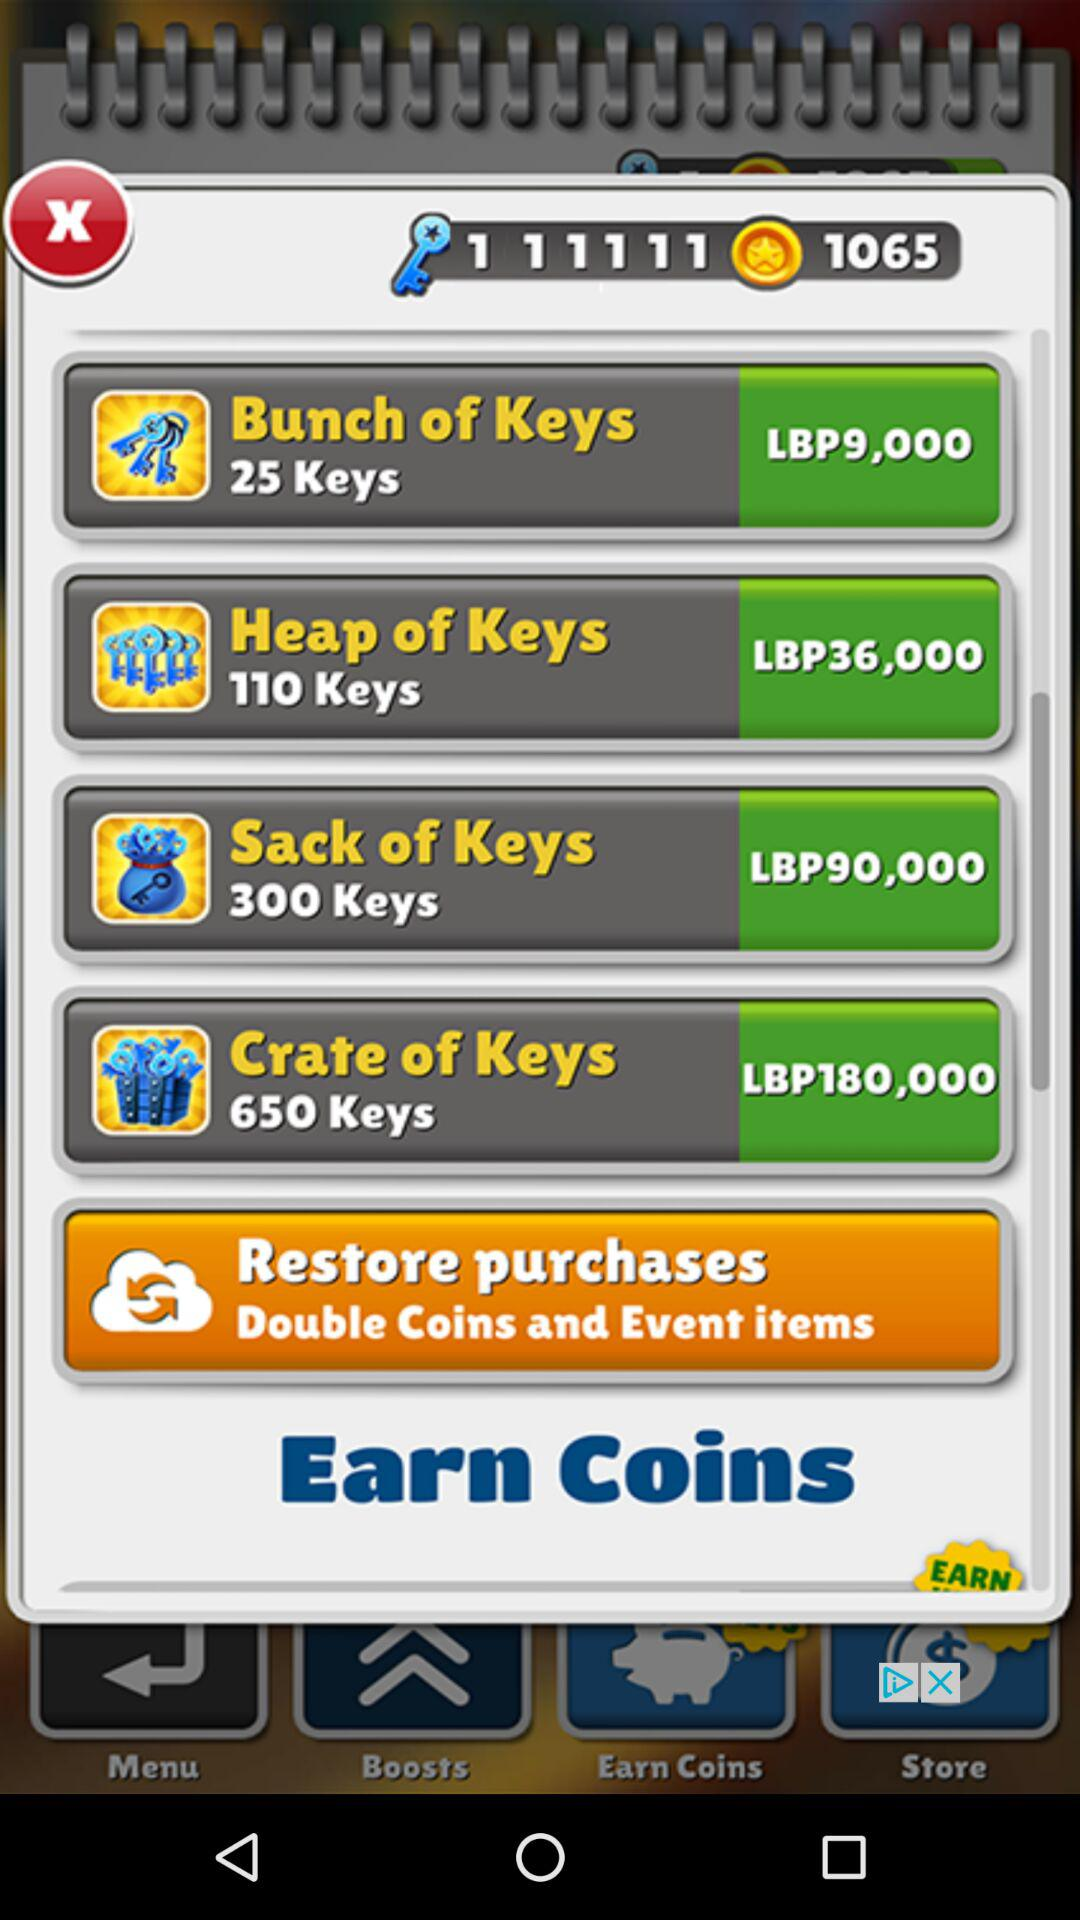How many keys are there for nine thousand LBP? There are 25 keys. 